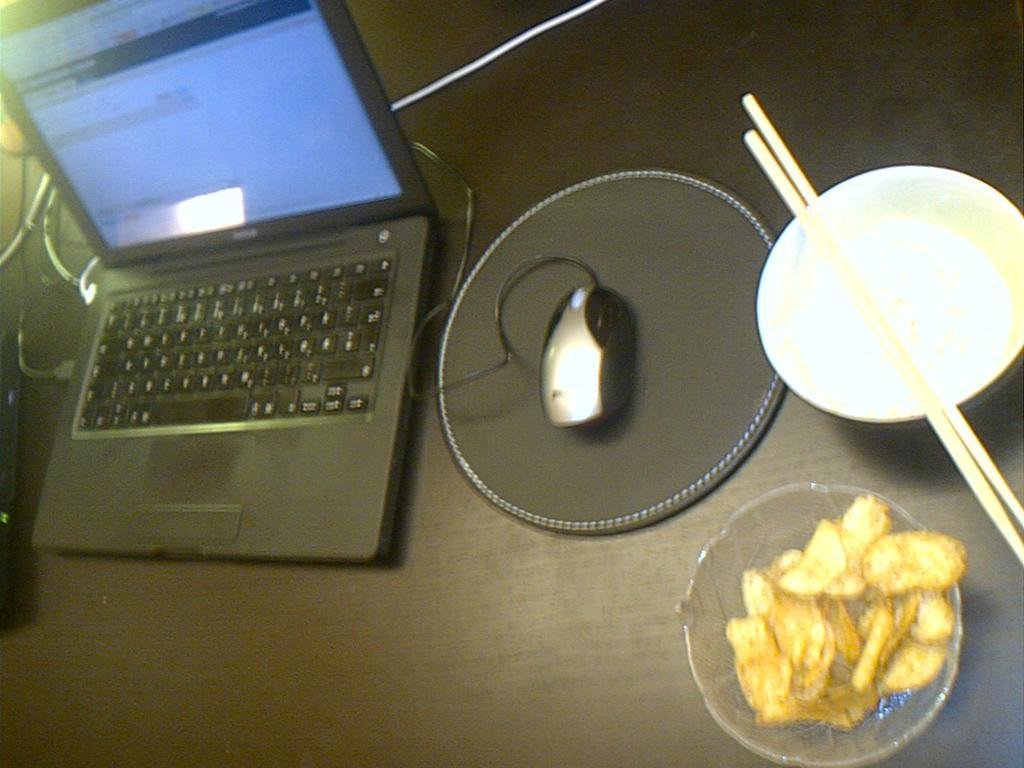What piece of furniture is present in the image? There is a desk in the image. What electronic device is on the desk? There is a laptop on the desk. What accessory is used with the laptop? There is a mouse on the desk. What is the mouse placed on? There is a mouse pad on the desk. What type of food items are in bowls on the desk? There are sticks and chips in separate bowls on the desk. How many chickens are sitting on the desk in the image? There are no chickens present in the image; the image only features a desk, laptop, mouse, mouse pad, sticks, and chips. 